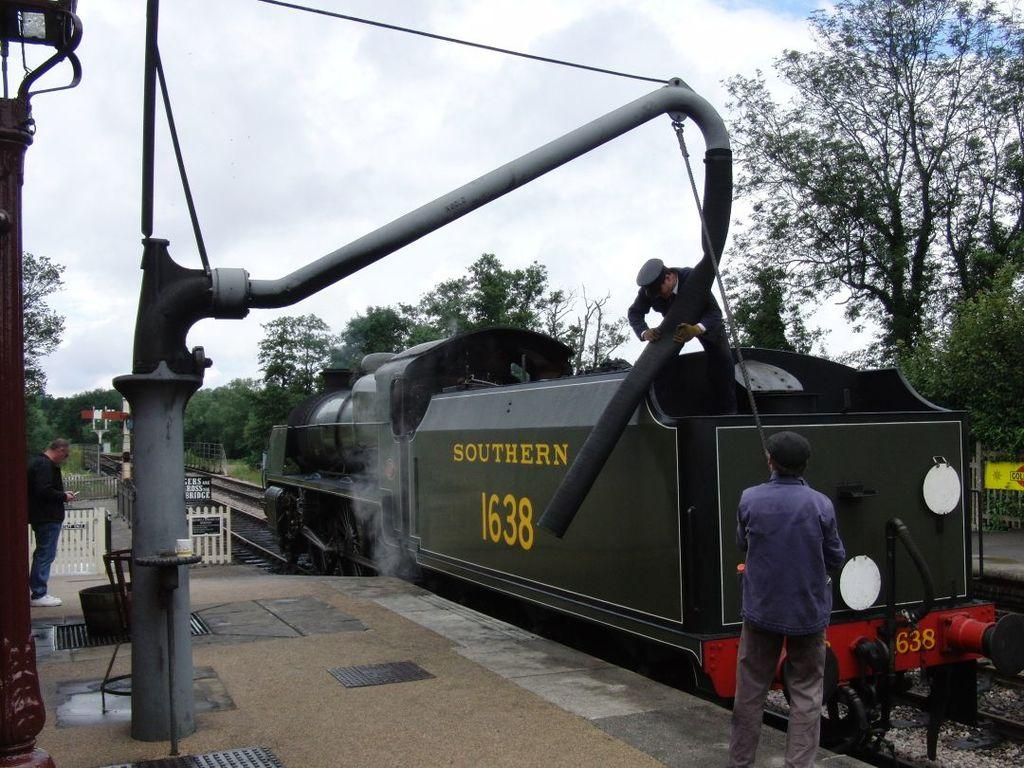What is the main subject of the image? The main subject of the image is a rail engine. Where is the rail engine located? The rail engine is on a railway track. Is there anyone near the rail engine? Yes, there is a man standing near the rail engine. What can be seen in the background of the image? There are trees in the image, and the sky is cloudy. What is the texture of the chance in the image? There is no chance present in the image, and therefore no texture can be described. 